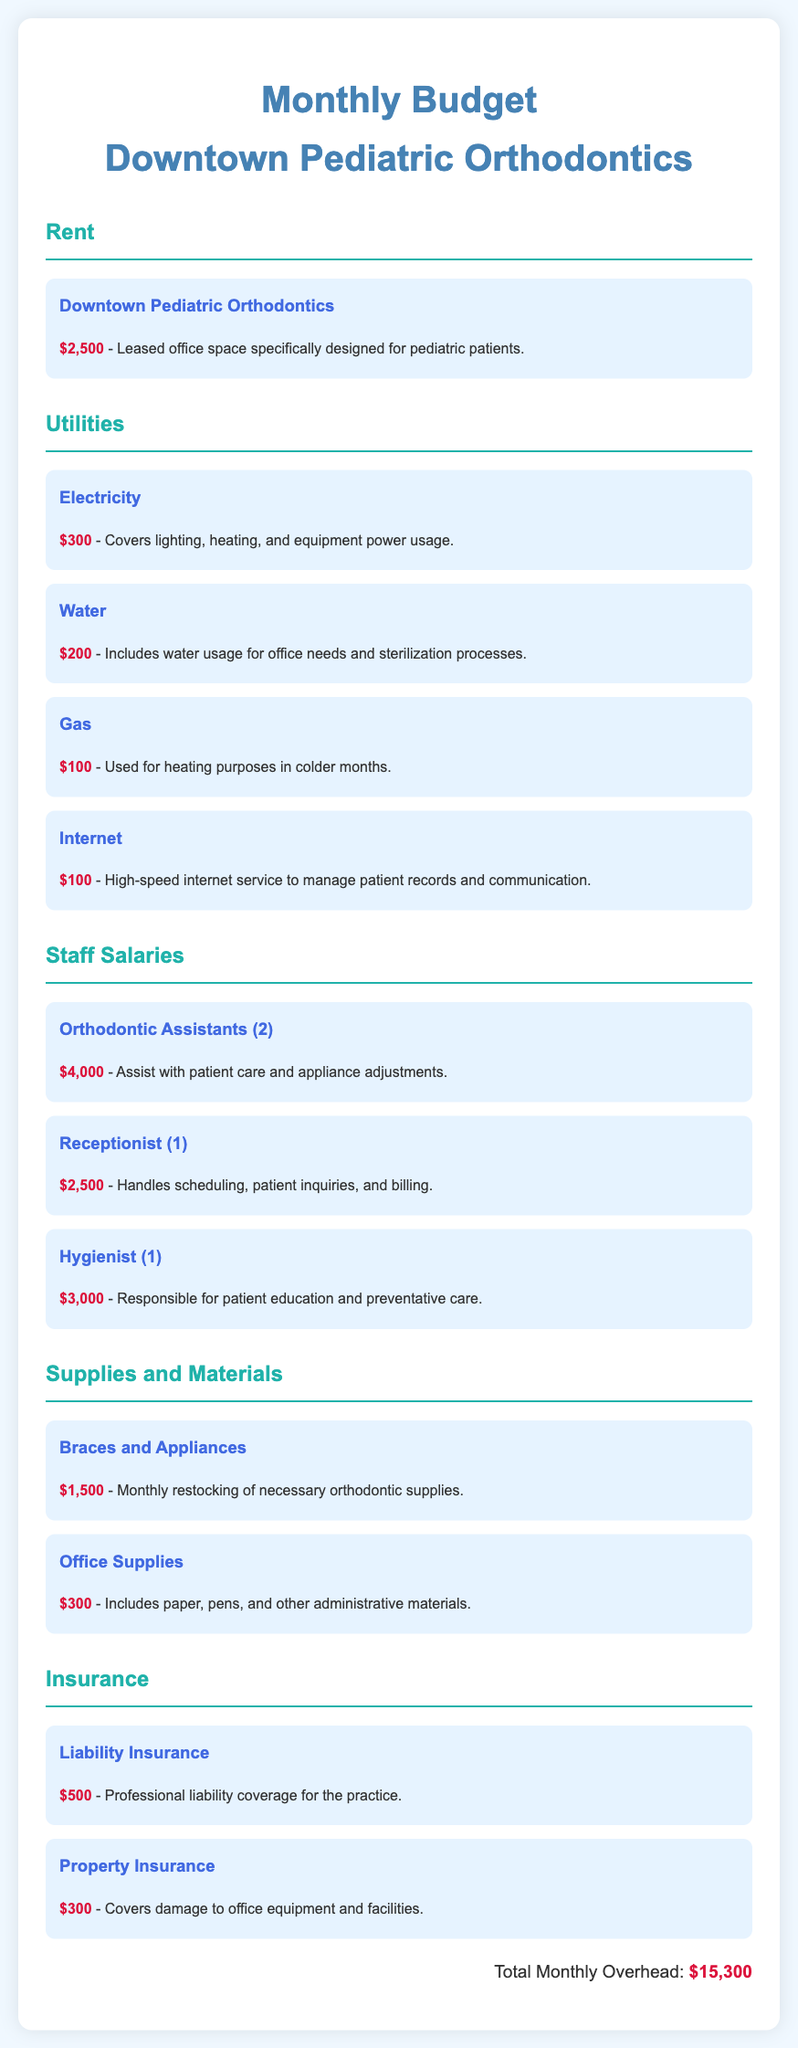What is the monthly rent expense? The monthly rent expense is stated directly in the document as $2,500.
Answer: $2,500 How much is allocated for electricity? The document specifies the cost for electricity is $300.
Answer: $300 How many Orthodontic Assistants are listed? The document indicates there are 2 Orthodontic Assistants mentioned under staff salaries.
Answer: 2 What is the total monthly overhead cost? The total monthly overhead cost is clearly summarized at the end of the document as $15,300.
Answer: $15,300 What is the cost associated with braces and appliances? The document states that the monthly cost for braces and appliances is $1,500.
Answer: $1,500 How much does the receptionist earn monthly? The document specifies the receptionist's salary as $2,500.
Answer: $2,500 What type of insurance is listed under liability? The document lists "Liability Insurance" specifically in the insurance section.
Answer: Liability Insurance What is the combined cost of water and gas utilities? Addition of water ($200) and gas ($100) gives a combined utility cost of $300.
Answer: $300 What is the cost for office supplies each month? The office supplies cost is noted as $300 in the document.
Answer: $300 